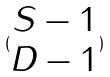<formula> <loc_0><loc_0><loc_500><loc_500>( \begin{matrix} S - 1 \\ D - 1 \end{matrix} )</formula> 